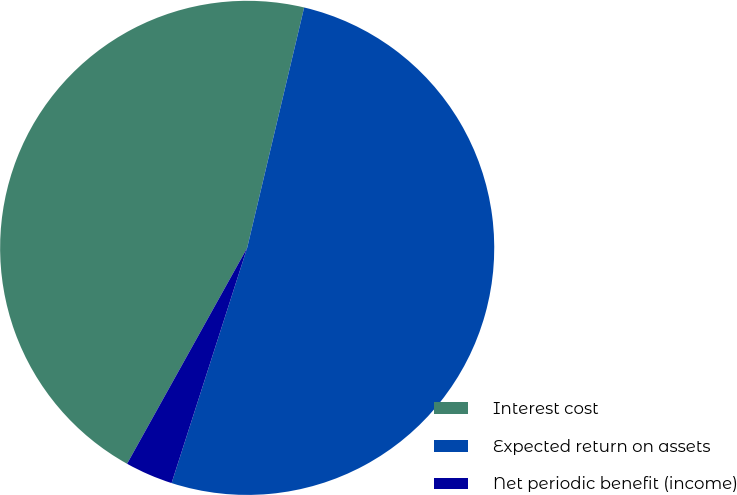Convert chart to OTSL. <chart><loc_0><loc_0><loc_500><loc_500><pie_chart><fcel>Interest cost<fcel>Expected return on assets<fcel>Net periodic benefit (income)<nl><fcel>45.63%<fcel>51.25%<fcel>3.13%<nl></chart> 